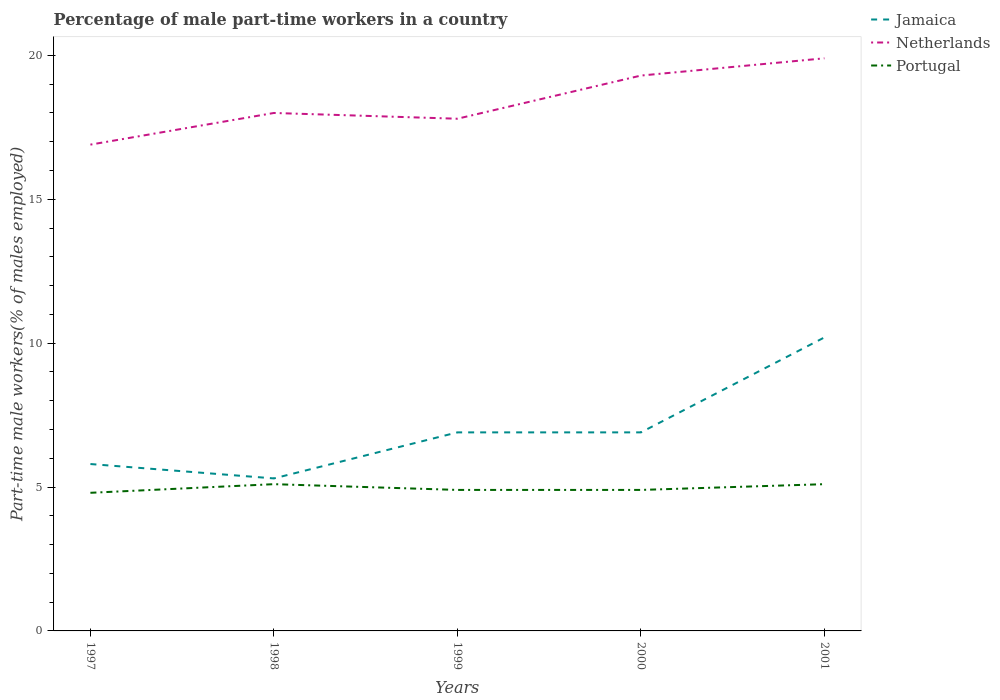Does the line corresponding to Jamaica intersect with the line corresponding to Portugal?
Your response must be concise. No. Across all years, what is the maximum percentage of male part-time workers in Portugal?
Ensure brevity in your answer.  4.8. In which year was the percentage of male part-time workers in Portugal maximum?
Keep it short and to the point. 1997. What is the total percentage of male part-time workers in Jamaica in the graph?
Ensure brevity in your answer.  -1.6. Is the percentage of male part-time workers in Netherlands strictly greater than the percentage of male part-time workers in Jamaica over the years?
Your answer should be very brief. No. How many lines are there?
Offer a terse response. 3. How are the legend labels stacked?
Provide a succinct answer. Vertical. What is the title of the graph?
Provide a short and direct response. Percentage of male part-time workers in a country. What is the label or title of the Y-axis?
Ensure brevity in your answer.  Part-time male workers(% of males employed). What is the Part-time male workers(% of males employed) of Jamaica in 1997?
Keep it short and to the point. 5.8. What is the Part-time male workers(% of males employed) in Netherlands in 1997?
Provide a succinct answer. 16.9. What is the Part-time male workers(% of males employed) of Portugal in 1997?
Offer a terse response. 4.8. What is the Part-time male workers(% of males employed) in Jamaica in 1998?
Offer a terse response. 5.3. What is the Part-time male workers(% of males employed) in Portugal in 1998?
Ensure brevity in your answer.  5.1. What is the Part-time male workers(% of males employed) in Jamaica in 1999?
Your response must be concise. 6.9. What is the Part-time male workers(% of males employed) in Netherlands in 1999?
Offer a very short reply. 17.8. What is the Part-time male workers(% of males employed) in Portugal in 1999?
Ensure brevity in your answer.  4.9. What is the Part-time male workers(% of males employed) of Jamaica in 2000?
Provide a short and direct response. 6.9. What is the Part-time male workers(% of males employed) of Netherlands in 2000?
Give a very brief answer. 19.3. What is the Part-time male workers(% of males employed) of Portugal in 2000?
Ensure brevity in your answer.  4.9. What is the Part-time male workers(% of males employed) in Jamaica in 2001?
Offer a very short reply. 10.2. What is the Part-time male workers(% of males employed) in Netherlands in 2001?
Make the answer very short. 19.9. What is the Part-time male workers(% of males employed) of Portugal in 2001?
Your answer should be compact. 5.1. Across all years, what is the maximum Part-time male workers(% of males employed) in Jamaica?
Offer a very short reply. 10.2. Across all years, what is the maximum Part-time male workers(% of males employed) in Netherlands?
Your answer should be compact. 19.9. Across all years, what is the maximum Part-time male workers(% of males employed) of Portugal?
Give a very brief answer. 5.1. Across all years, what is the minimum Part-time male workers(% of males employed) in Jamaica?
Offer a very short reply. 5.3. Across all years, what is the minimum Part-time male workers(% of males employed) of Netherlands?
Offer a terse response. 16.9. Across all years, what is the minimum Part-time male workers(% of males employed) of Portugal?
Provide a short and direct response. 4.8. What is the total Part-time male workers(% of males employed) in Jamaica in the graph?
Your answer should be very brief. 35.1. What is the total Part-time male workers(% of males employed) in Netherlands in the graph?
Your answer should be compact. 91.9. What is the total Part-time male workers(% of males employed) of Portugal in the graph?
Offer a terse response. 24.8. What is the difference between the Part-time male workers(% of males employed) of Netherlands in 1997 and that in 1998?
Your response must be concise. -1.1. What is the difference between the Part-time male workers(% of males employed) in Portugal in 1997 and that in 1998?
Give a very brief answer. -0.3. What is the difference between the Part-time male workers(% of males employed) in Portugal in 1997 and that in 1999?
Give a very brief answer. -0.1. What is the difference between the Part-time male workers(% of males employed) in Jamaica in 1997 and that in 2000?
Your answer should be compact. -1.1. What is the difference between the Part-time male workers(% of males employed) of Netherlands in 1997 and that in 2000?
Your answer should be compact. -2.4. What is the difference between the Part-time male workers(% of males employed) of Portugal in 1997 and that in 2000?
Your answer should be very brief. -0.1. What is the difference between the Part-time male workers(% of males employed) in Portugal in 1997 and that in 2001?
Offer a terse response. -0.3. What is the difference between the Part-time male workers(% of males employed) in Netherlands in 1998 and that in 1999?
Ensure brevity in your answer.  0.2. What is the difference between the Part-time male workers(% of males employed) in Netherlands in 1998 and that in 2000?
Your answer should be compact. -1.3. What is the difference between the Part-time male workers(% of males employed) in Netherlands in 1998 and that in 2001?
Keep it short and to the point. -1.9. What is the difference between the Part-time male workers(% of males employed) of Portugal in 1999 and that in 2000?
Your response must be concise. 0. What is the difference between the Part-time male workers(% of males employed) of Jamaica in 1999 and that in 2001?
Provide a short and direct response. -3.3. What is the difference between the Part-time male workers(% of males employed) of Portugal in 2000 and that in 2001?
Provide a succinct answer. -0.2. What is the difference between the Part-time male workers(% of males employed) in Netherlands in 1997 and the Part-time male workers(% of males employed) in Portugal in 1999?
Make the answer very short. 12. What is the difference between the Part-time male workers(% of males employed) of Jamaica in 1997 and the Part-time male workers(% of males employed) of Portugal in 2000?
Ensure brevity in your answer.  0.9. What is the difference between the Part-time male workers(% of males employed) in Jamaica in 1997 and the Part-time male workers(% of males employed) in Netherlands in 2001?
Your answer should be compact. -14.1. What is the difference between the Part-time male workers(% of males employed) of Jamaica in 1997 and the Part-time male workers(% of males employed) of Portugal in 2001?
Your answer should be very brief. 0.7. What is the difference between the Part-time male workers(% of males employed) of Netherlands in 1997 and the Part-time male workers(% of males employed) of Portugal in 2001?
Your answer should be very brief. 11.8. What is the difference between the Part-time male workers(% of males employed) of Jamaica in 1998 and the Part-time male workers(% of males employed) of Netherlands in 1999?
Your answer should be compact. -12.5. What is the difference between the Part-time male workers(% of males employed) in Jamaica in 1998 and the Part-time male workers(% of males employed) in Netherlands in 2000?
Provide a short and direct response. -14. What is the difference between the Part-time male workers(% of males employed) of Jamaica in 1998 and the Part-time male workers(% of males employed) of Portugal in 2000?
Your answer should be compact. 0.4. What is the difference between the Part-time male workers(% of males employed) in Jamaica in 1998 and the Part-time male workers(% of males employed) in Netherlands in 2001?
Offer a very short reply. -14.6. What is the difference between the Part-time male workers(% of males employed) in Netherlands in 1998 and the Part-time male workers(% of males employed) in Portugal in 2001?
Give a very brief answer. 12.9. What is the difference between the Part-time male workers(% of males employed) in Jamaica in 1999 and the Part-time male workers(% of males employed) in Portugal in 2000?
Ensure brevity in your answer.  2. What is the difference between the Part-time male workers(% of males employed) of Netherlands in 1999 and the Part-time male workers(% of males employed) of Portugal in 2000?
Offer a very short reply. 12.9. What is the difference between the Part-time male workers(% of males employed) in Jamaica in 1999 and the Part-time male workers(% of males employed) in Netherlands in 2001?
Give a very brief answer. -13. What is the difference between the Part-time male workers(% of males employed) in Jamaica in 1999 and the Part-time male workers(% of males employed) in Portugal in 2001?
Offer a terse response. 1.8. What is the difference between the Part-time male workers(% of males employed) of Jamaica in 2000 and the Part-time male workers(% of males employed) of Netherlands in 2001?
Give a very brief answer. -13. What is the difference between the Part-time male workers(% of males employed) of Jamaica in 2000 and the Part-time male workers(% of males employed) of Portugal in 2001?
Your response must be concise. 1.8. What is the difference between the Part-time male workers(% of males employed) of Netherlands in 2000 and the Part-time male workers(% of males employed) of Portugal in 2001?
Give a very brief answer. 14.2. What is the average Part-time male workers(% of males employed) in Jamaica per year?
Your answer should be very brief. 7.02. What is the average Part-time male workers(% of males employed) of Netherlands per year?
Keep it short and to the point. 18.38. What is the average Part-time male workers(% of males employed) of Portugal per year?
Your answer should be compact. 4.96. In the year 1997, what is the difference between the Part-time male workers(% of males employed) in Jamaica and Part-time male workers(% of males employed) in Netherlands?
Offer a very short reply. -11.1. In the year 1997, what is the difference between the Part-time male workers(% of males employed) of Jamaica and Part-time male workers(% of males employed) of Portugal?
Your answer should be very brief. 1. In the year 1998, what is the difference between the Part-time male workers(% of males employed) in Jamaica and Part-time male workers(% of males employed) in Netherlands?
Make the answer very short. -12.7. In the year 1998, what is the difference between the Part-time male workers(% of males employed) in Jamaica and Part-time male workers(% of males employed) in Portugal?
Provide a succinct answer. 0.2. In the year 1999, what is the difference between the Part-time male workers(% of males employed) of Netherlands and Part-time male workers(% of males employed) of Portugal?
Make the answer very short. 12.9. In the year 2001, what is the difference between the Part-time male workers(% of males employed) in Jamaica and Part-time male workers(% of males employed) in Netherlands?
Ensure brevity in your answer.  -9.7. What is the ratio of the Part-time male workers(% of males employed) of Jamaica in 1997 to that in 1998?
Give a very brief answer. 1.09. What is the ratio of the Part-time male workers(% of males employed) of Netherlands in 1997 to that in 1998?
Offer a very short reply. 0.94. What is the ratio of the Part-time male workers(% of males employed) in Jamaica in 1997 to that in 1999?
Make the answer very short. 0.84. What is the ratio of the Part-time male workers(% of males employed) in Netherlands in 1997 to that in 1999?
Your answer should be compact. 0.95. What is the ratio of the Part-time male workers(% of males employed) of Portugal in 1997 to that in 1999?
Offer a terse response. 0.98. What is the ratio of the Part-time male workers(% of males employed) of Jamaica in 1997 to that in 2000?
Your response must be concise. 0.84. What is the ratio of the Part-time male workers(% of males employed) in Netherlands in 1997 to that in 2000?
Give a very brief answer. 0.88. What is the ratio of the Part-time male workers(% of males employed) of Portugal in 1997 to that in 2000?
Ensure brevity in your answer.  0.98. What is the ratio of the Part-time male workers(% of males employed) in Jamaica in 1997 to that in 2001?
Provide a succinct answer. 0.57. What is the ratio of the Part-time male workers(% of males employed) in Netherlands in 1997 to that in 2001?
Provide a succinct answer. 0.85. What is the ratio of the Part-time male workers(% of males employed) in Jamaica in 1998 to that in 1999?
Offer a very short reply. 0.77. What is the ratio of the Part-time male workers(% of males employed) of Netherlands in 1998 to that in 1999?
Offer a terse response. 1.01. What is the ratio of the Part-time male workers(% of males employed) in Portugal in 1998 to that in 1999?
Offer a terse response. 1.04. What is the ratio of the Part-time male workers(% of males employed) in Jamaica in 1998 to that in 2000?
Provide a succinct answer. 0.77. What is the ratio of the Part-time male workers(% of males employed) in Netherlands in 1998 to that in 2000?
Provide a short and direct response. 0.93. What is the ratio of the Part-time male workers(% of males employed) of Portugal in 1998 to that in 2000?
Ensure brevity in your answer.  1.04. What is the ratio of the Part-time male workers(% of males employed) of Jamaica in 1998 to that in 2001?
Your answer should be very brief. 0.52. What is the ratio of the Part-time male workers(% of males employed) in Netherlands in 1998 to that in 2001?
Keep it short and to the point. 0.9. What is the ratio of the Part-time male workers(% of males employed) of Netherlands in 1999 to that in 2000?
Offer a very short reply. 0.92. What is the ratio of the Part-time male workers(% of males employed) in Jamaica in 1999 to that in 2001?
Make the answer very short. 0.68. What is the ratio of the Part-time male workers(% of males employed) in Netherlands in 1999 to that in 2001?
Ensure brevity in your answer.  0.89. What is the ratio of the Part-time male workers(% of males employed) of Portugal in 1999 to that in 2001?
Your response must be concise. 0.96. What is the ratio of the Part-time male workers(% of males employed) in Jamaica in 2000 to that in 2001?
Keep it short and to the point. 0.68. What is the ratio of the Part-time male workers(% of males employed) in Netherlands in 2000 to that in 2001?
Offer a very short reply. 0.97. What is the ratio of the Part-time male workers(% of males employed) of Portugal in 2000 to that in 2001?
Ensure brevity in your answer.  0.96. What is the difference between the highest and the second highest Part-time male workers(% of males employed) in Netherlands?
Give a very brief answer. 0.6. What is the difference between the highest and the lowest Part-time male workers(% of males employed) of Jamaica?
Your answer should be very brief. 4.9. What is the difference between the highest and the lowest Part-time male workers(% of males employed) in Netherlands?
Your answer should be compact. 3. What is the difference between the highest and the lowest Part-time male workers(% of males employed) in Portugal?
Provide a short and direct response. 0.3. 